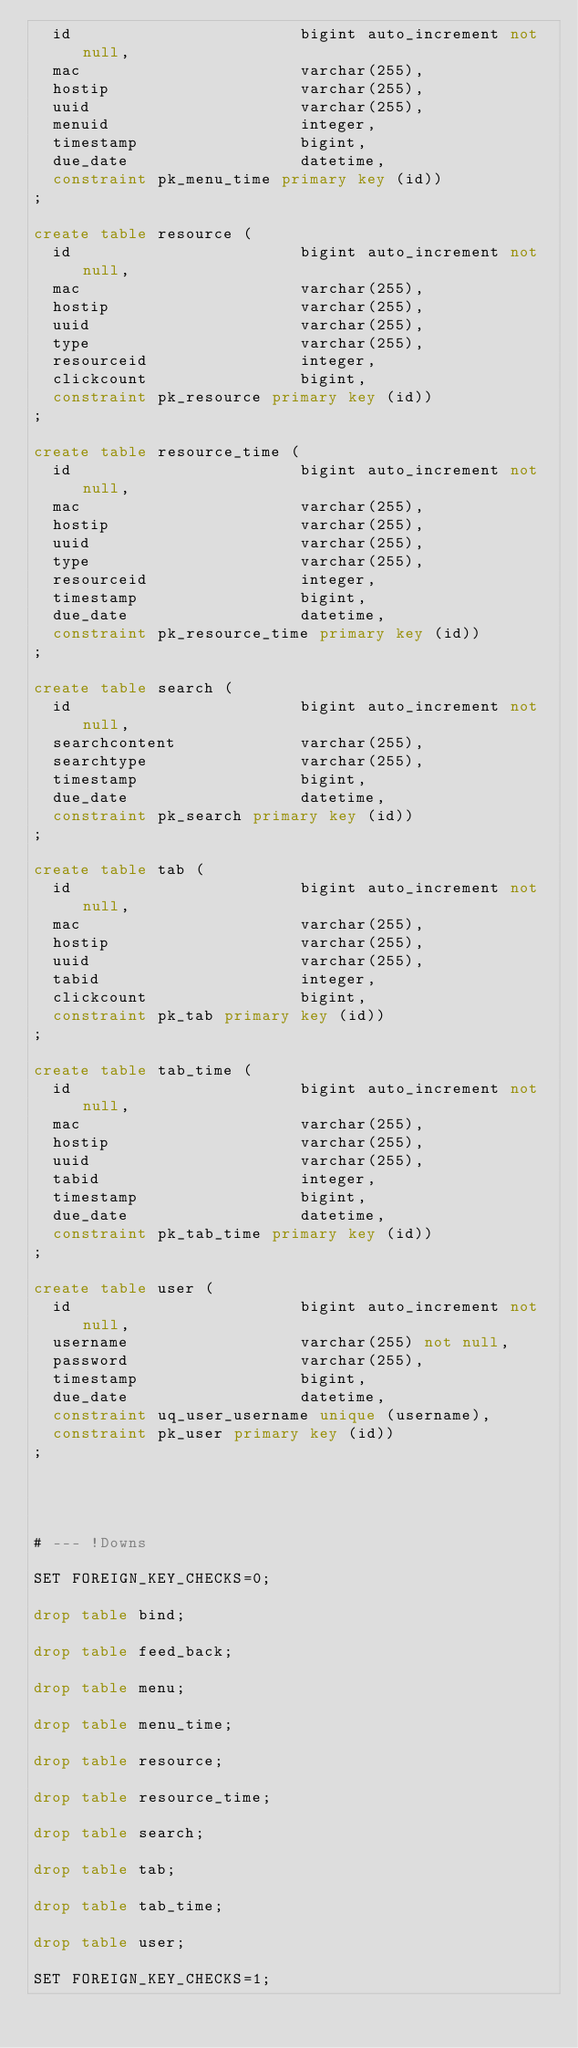<code> <loc_0><loc_0><loc_500><loc_500><_SQL_>  id                        bigint auto_increment not null,
  mac                       varchar(255),
  hostip                    varchar(255),
  uuid                      varchar(255),
  menuid                    integer,
  timestamp                 bigint,
  due_date                  datetime,
  constraint pk_menu_time primary key (id))
;

create table resource (
  id                        bigint auto_increment not null,
  mac                       varchar(255),
  hostip                    varchar(255),
  uuid                      varchar(255),
  type                      varchar(255),
  resourceid                integer,
  clickcount                bigint,
  constraint pk_resource primary key (id))
;

create table resource_time (
  id                        bigint auto_increment not null,
  mac                       varchar(255),
  hostip                    varchar(255),
  uuid                      varchar(255),
  type                      varchar(255),
  resourceid                integer,
  timestamp                 bigint,
  due_date                  datetime,
  constraint pk_resource_time primary key (id))
;

create table search (
  id                        bigint auto_increment not null,
  searchcontent             varchar(255),
  searchtype                varchar(255),
  timestamp                 bigint,
  due_date                  datetime,
  constraint pk_search primary key (id))
;

create table tab (
  id                        bigint auto_increment not null,
  mac                       varchar(255),
  hostip                    varchar(255),
  uuid                      varchar(255),
  tabid                     integer,
  clickcount                bigint,
  constraint pk_tab primary key (id))
;

create table tab_time (
  id                        bigint auto_increment not null,
  mac                       varchar(255),
  hostip                    varchar(255),
  uuid                      varchar(255),
  tabid                     integer,
  timestamp                 bigint,
  due_date                  datetime,
  constraint pk_tab_time primary key (id))
;

create table user (
  id                        bigint auto_increment not null,
  username                  varchar(255) not null,
  password                  varchar(255),
  timestamp                 bigint,
  due_date                  datetime,
  constraint uq_user_username unique (username),
  constraint pk_user primary key (id))
;




# --- !Downs

SET FOREIGN_KEY_CHECKS=0;

drop table bind;

drop table feed_back;

drop table menu;

drop table menu_time;

drop table resource;

drop table resource_time;

drop table search;

drop table tab;

drop table tab_time;

drop table user;

SET FOREIGN_KEY_CHECKS=1;

</code> 